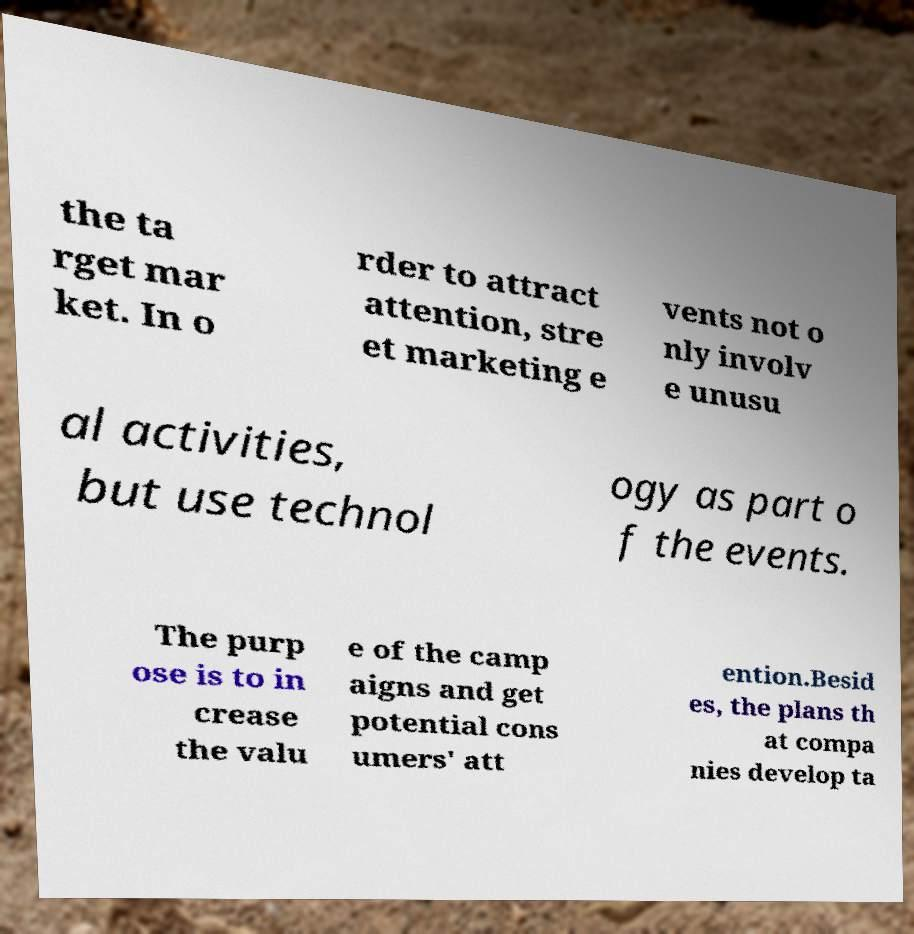Can you read and provide the text displayed in the image?This photo seems to have some interesting text. Can you extract and type it out for me? the ta rget mar ket. In o rder to attract attention, stre et marketing e vents not o nly involv e unusu al activities, but use technol ogy as part o f the events. The purp ose is to in crease the valu e of the camp aigns and get potential cons umers' att ention.Besid es, the plans th at compa nies develop ta 